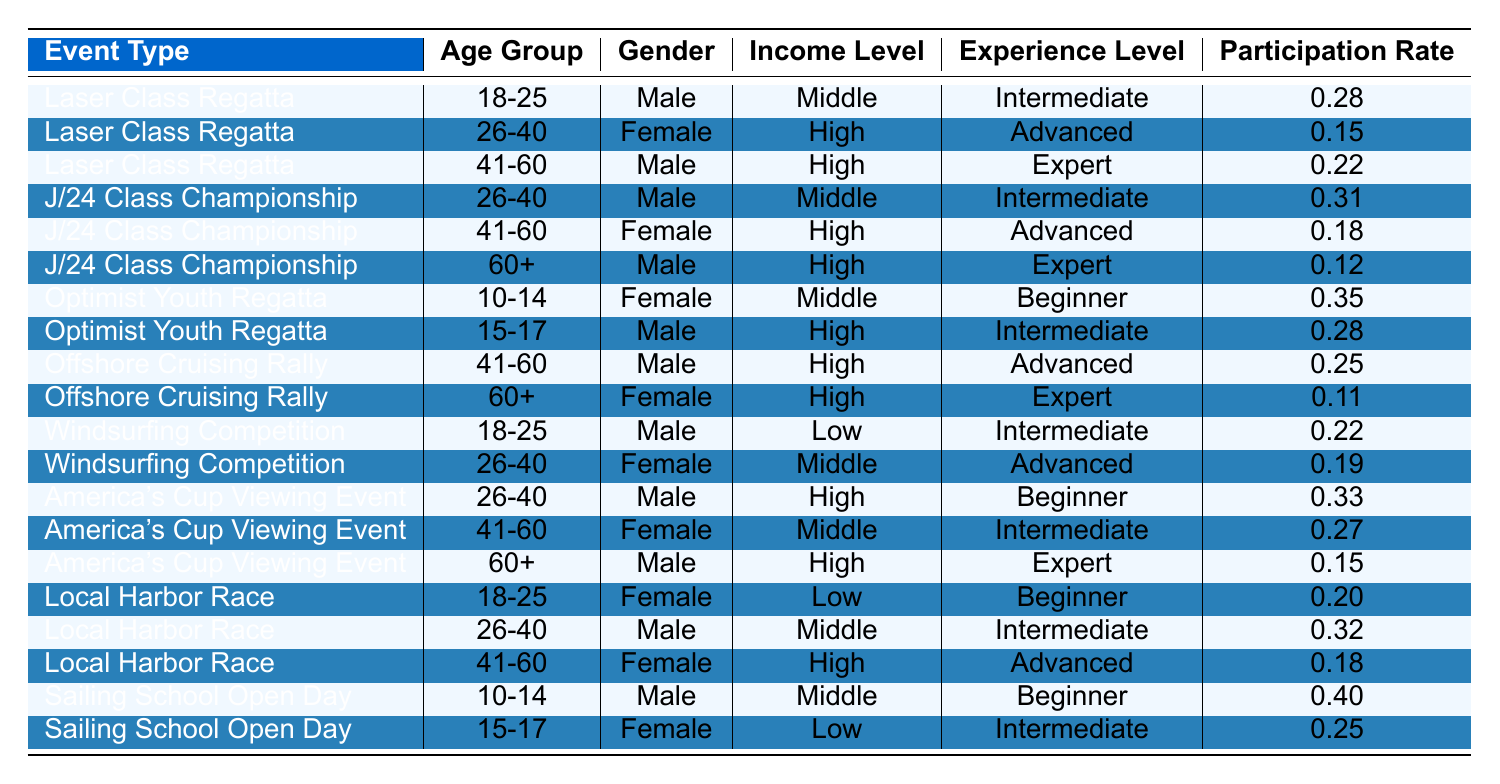What is the highest participation rate among the events? The participation rates in the table are: 0.28, 0.15, 0.22, 0.31, 0.18, 0.12, 0.35, 0.28, 0.25, 0.11, 0.22, 0.19, 0.33, 0.27, 0.15, 0.20, 0.32, 0.18, 0.40, and 0.25. The highest value is 0.40 from the Sailing School Open Day.
Answer: 0.40 Which age group has the highest participation rate in the J/24 Class Championship? The participation rates for the J/24 Class Championship's age groups are: 0.31 for 26-40, 0.18 for 41-60, and 0.12 for 60+. Thus, the highest is 0.31 for the 26-40 age group.
Answer: 26-40 Are there more male or female participants in the Local Harbor Race? In the Local Harbor Race, the data shows 2 males (18-25 and 26-40) and 1 female (41-60). Therefore, there are more males than females.
Answer: Male What is the average participation rate for the Laser Class Regatta? The participation rates for the Laser Class Regatta are: 0.28, 0.15, and 0.22. Summing these gives 0.65, and with 3 data points, the average is 0.65/3 = 0.2167 (approximately 0.22).
Answer: 0.22 Is the participation rate for the Offshore Cruising Rally greater than that of all the other events combined? For the Offshore Cruising Rally, the rates are 0.25 and 0.11, summing to 0.36. Combined participation rates for all other events (excluding Offshore Cruising Rally) is 0.28 + 0.15 + 0.22 + 0.31 + 0.18 + 0.12 + 0.35 + 0.28 + 0.22 + 0.19 + 0.33 + 0.27 + 0.20 + 0.32 + 0.18 + 0.40 + 0.25 = 2.74. Since 0.36 < 2.74, the answer is no.
Answer: No What is the income level of the youngest group in the Optimist Youth Regatta? In the Optimist Youth Regatta, the 10-14 age group is female with a participation rate of 0.35 and is categorized as having a middle income level.
Answer: Middle Calculate the total participation rate for female participants across all events. The total participation rates for females in the data are: 0.15 (Laser Class), 0.18 (J/24), 0.35 (Optimist), 0.11 (Offshore), 0.19 (Windsurfing), 0.27 (America's Cup), 0.20 (Local Harbor), 0.25 (Sailing School) = 0.15 + 0.18 + 0.35 + 0.11 + 0.19 + 0.27 + 0.20 + 0.25 = 1.30.
Answer: 1.30 Determine whether more female participants have advanced experience compared to intermediate experience across all events. The total female advanced experience rates are: 0.15 (Laser Class) + 0.18 (J/24) + 0.11 (Offshore) + 0.27 (America's Cup) + 0.18 (Local Harbor) = 0.89. The total female intermediate experience rates are: 0.35 (Optimist) + 0.28 (J/24) + 0.22 (Windsurfing) + 0.27 (America's Cup) = 1.12. Since 0.89 < 1.12, more female participants have intermediate experience.
Answer: Intermediate Which event has the lowest participation rate for the 60+ age group? For the 60+ age group, the participation rates are 0.12 for J/24 Class, 0.11 for Offshore Cruising Rally, and 0.15 for America’s Cup. The lowest is 0.11 from the Offshore Cruising Rally.
Answer: Offshore Cruising Rally What percentage of total participants are males across all events? Male participation across events can be summed: 0.28 + 0.22 + 0.31 + 0.25 + 0.22 + 0.33 + 0.32 + 0.40 = 2.28. Total participation across all events is 0.28 + 0.15 + 0.22 + 0.31 + 0.18 + 0.12 + 0.35 + 0.28 + 0.25 + 0.11 + 0.22 + 0.19 + 0.33 + 0.27 + 0.15 + 0.20 + 0.32 + 0.18 + 0.40 + 0.25 = 4.14. Thus, male participation rate is (2.28 / 4.14) * 100% = 55%.
Answer: 55% 